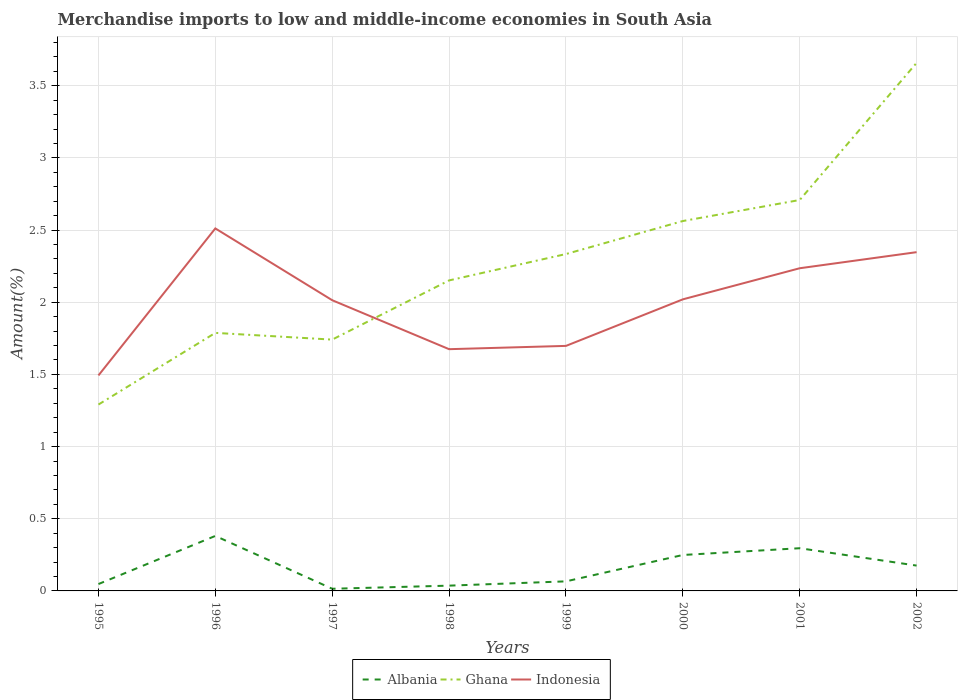Is the number of lines equal to the number of legend labels?
Offer a terse response. Yes. Across all years, what is the maximum percentage of amount earned from merchandise imports in Indonesia?
Provide a short and direct response. 1.49. In which year was the percentage of amount earned from merchandise imports in Ghana maximum?
Offer a terse response. 1995. What is the total percentage of amount earned from merchandise imports in Ghana in the graph?
Provide a succinct answer. -0.97. What is the difference between the highest and the second highest percentage of amount earned from merchandise imports in Ghana?
Offer a very short reply. 2.37. How many years are there in the graph?
Ensure brevity in your answer.  8. What is the difference between two consecutive major ticks on the Y-axis?
Ensure brevity in your answer.  0.5. What is the title of the graph?
Give a very brief answer. Merchandise imports to low and middle-income economies in South Asia. Does "Burkina Faso" appear as one of the legend labels in the graph?
Provide a succinct answer. No. What is the label or title of the X-axis?
Provide a short and direct response. Years. What is the label or title of the Y-axis?
Offer a terse response. Amount(%). What is the Amount(%) in Albania in 1995?
Provide a succinct answer. 0.05. What is the Amount(%) of Ghana in 1995?
Offer a terse response. 1.29. What is the Amount(%) in Indonesia in 1995?
Your answer should be compact. 1.49. What is the Amount(%) of Albania in 1996?
Offer a terse response. 0.38. What is the Amount(%) of Ghana in 1996?
Your response must be concise. 1.79. What is the Amount(%) of Indonesia in 1996?
Your answer should be compact. 2.51. What is the Amount(%) in Albania in 1997?
Ensure brevity in your answer.  0.01. What is the Amount(%) in Ghana in 1997?
Offer a very short reply. 1.74. What is the Amount(%) of Indonesia in 1997?
Ensure brevity in your answer.  2.01. What is the Amount(%) in Albania in 1998?
Offer a terse response. 0.04. What is the Amount(%) in Ghana in 1998?
Ensure brevity in your answer.  2.15. What is the Amount(%) of Indonesia in 1998?
Offer a very short reply. 1.67. What is the Amount(%) of Albania in 1999?
Your response must be concise. 0.07. What is the Amount(%) of Ghana in 1999?
Your response must be concise. 2.33. What is the Amount(%) in Indonesia in 1999?
Make the answer very short. 1.7. What is the Amount(%) in Albania in 2000?
Offer a very short reply. 0.25. What is the Amount(%) in Ghana in 2000?
Keep it short and to the point. 2.56. What is the Amount(%) of Indonesia in 2000?
Keep it short and to the point. 2.02. What is the Amount(%) in Albania in 2001?
Give a very brief answer. 0.3. What is the Amount(%) of Ghana in 2001?
Give a very brief answer. 2.71. What is the Amount(%) in Indonesia in 2001?
Provide a short and direct response. 2.24. What is the Amount(%) of Albania in 2002?
Ensure brevity in your answer.  0.18. What is the Amount(%) in Ghana in 2002?
Ensure brevity in your answer.  3.66. What is the Amount(%) of Indonesia in 2002?
Offer a very short reply. 2.35. Across all years, what is the maximum Amount(%) of Albania?
Offer a very short reply. 0.38. Across all years, what is the maximum Amount(%) of Ghana?
Keep it short and to the point. 3.66. Across all years, what is the maximum Amount(%) in Indonesia?
Provide a short and direct response. 2.51. Across all years, what is the minimum Amount(%) in Albania?
Your response must be concise. 0.01. Across all years, what is the minimum Amount(%) of Ghana?
Ensure brevity in your answer.  1.29. Across all years, what is the minimum Amount(%) in Indonesia?
Make the answer very short. 1.49. What is the total Amount(%) of Albania in the graph?
Ensure brevity in your answer.  1.27. What is the total Amount(%) of Ghana in the graph?
Your response must be concise. 18.24. What is the total Amount(%) in Indonesia in the graph?
Ensure brevity in your answer.  15.99. What is the difference between the Amount(%) in Albania in 1995 and that in 1996?
Make the answer very short. -0.33. What is the difference between the Amount(%) in Ghana in 1995 and that in 1996?
Your response must be concise. -0.5. What is the difference between the Amount(%) in Indonesia in 1995 and that in 1996?
Your response must be concise. -1.02. What is the difference between the Amount(%) of Albania in 1995 and that in 1997?
Your response must be concise. 0.03. What is the difference between the Amount(%) of Ghana in 1995 and that in 1997?
Provide a succinct answer. -0.45. What is the difference between the Amount(%) in Indonesia in 1995 and that in 1997?
Offer a very short reply. -0.52. What is the difference between the Amount(%) in Albania in 1995 and that in 1998?
Your answer should be compact. 0.01. What is the difference between the Amount(%) of Ghana in 1995 and that in 1998?
Provide a succinct answer. -0.86. What is the difference between the Amount(%) of Indonesia in 1995 and that in 1998?
Make the answer very short. -0.18. What is the difference between the Amount(%) in Albania in 1995 and that in 1999?
Your answer should be very brief. -0.02. What is the difference between the Amount(%) in Ghana in 1995 and that in 1999?
Your answer should be very brief. -1.04. What is the difference between the Amount(%) of Indonesia in 1995 and that in 1999?
Give a very brief answer. -0.2. What is the difference between the Amount(%) of Albania in 1995 and that in 2000?
Your answer should be very brief. -0.2. What is the difference between the Amount(%) in Ghana in 1995 and that in 2000?
Offer a terse response. -1.27. What is the difference between the Amount(%) in Indonesia in 1995 and that in 2000?
Give a very brief answer. -0.53. What is the difference between the Amount(%) of Albania in 1995 and that in 2001?
Provide a succinct answer. -0.25. What is the difference between the Amount(%) of Ghana in 1995 and that in 2001?
Provide a succinct answer. -1.42. What is the difference between the Amount(%) in Indonesia in 1995 and that in 2001?
Offer a very short reply. -0.74. What is the difference between the Amount(%) of Albania in 1995 and that in 2002?
Provide a short and direct response. -0.13. What is the difference between the Amount(%) of Ghana in 1995 and that in 2002?
Provide a succinct answer. -2.37. What is the difference between the Amount(%) in Indonesia in 1995 and that in 2002?
Provide a succinct answer. -0.85. What is the difference between the Amount(%) of Albania in 1996 and that in 1997?
Ensure brevity in your answer.  0.37. What is the difference between the Amount(%) in Ghana in 1996 and that in 1997?
Make the answer very short. 0.05. What is the difference between the Amount(%) of Indonesia in 1996 and that in 1997?
Provide a short and direct response. 0.5. What is the difference between the Amount(%) of Albania in 1996 and that in 1998?
Your response must be concise. 0.34. What is the difference between the Amount(%) of Ghana in 1996 and that in 1998?
Your answer should be compact. -0.36. What is the difference between the Amount(%) of Indonesia in 1996 and that in 1998?
Provide a short and direct response. 0.84. What is the difference between the Amount(%) of Albania in 1996 and that in 1999?
Your answer should be very brief. 0.31. What is the difference between the Amount(%) in Ghana in 1996 and that in 1999?
Your answer should be compact. -0.55. What is the difference between the Amount(%) in Indonesia in 1996 and that in 1999?
Your response must be concise. 0.81. What is the difference between the Amount(%) of Albania in 1996 and that in 2000?
Make the answer very short. 0.13. What is the difference between the Amount(%) in Ghana in 1996 and that in 2000?
Your answer should be very brief. -0.78. What is the difference between the Amount(%) in Indonesia in 1996 and that in 2000?
Ensure brevity in your answer.  0.49. What is the difference between the Amount(%) of Albania in 1996 and that in 2001?
Give a very brief answer. 0.09. What is the difference between the Amount(%) of Ghana in 1996 and that in 2001?
Keep it short and to the point. -0.92. What is the difference between the Amount(%) in Indonesia in 1996 and that in 2001?
Provide a short and direct response. 0.28. What is the difference between the Amount(%) in Albania in 1996 and that in 2002?
Offer a very short reply. 0.21. What is the difference between the Amount(%) in Ghana in 1996 and that in 2002?
Provide a succinct answer. -1.87. What is the difference between the Amount(%) of Indonesia in 1996 and that in 2002?
Ensure brevity in your answer.  0.16. What is the difference between the Amount(%) of Albania in 1997 and that in 1998?
Your answer should be compact. -0.02. What is the difference between the Amount(%) in Ghana in 1997 and that in 1998?
Your response must be concise. -0.41. What is the difference between the Amount(%) in Indonesia in 1997 and that in 1998?
Your answer should be compact. 0.34. What is the difference between the Amount(%) of Albania in 1997 and that in 1999?
Your response must be concise. -0.05. What is the difference between the Amount(%) in Ghana in 1997 and that in 1999?
Keep it short and to the point. -0.59. What is the difference between the Amount(%) in Indonesia in 1997 and that in 1999?
Provide a succinct answer. 0.32. What is the difference between the Amount(%) in Albania in 1997 and that in 2000?
Your answer should be very brief. -0.23. What is the difference between the Amount(%) of Ghana in 1997 and that in 2000?
Give a very brief answer. -0.82. What is the difference between the Amount(%) in Indonesia in 1997 and that in 2000?
Provide a succinct answer. -0.01. What is the difference between the Amount(%) of Albania in 1997 and that in 2001?
Your response must be concise. -0.28. What is the difference between the Amount(%) in Ghana in 1997 and that in 2001?
Provide a short and direct response. -0.97. What is the difference between the Amount(%) in Indonesia in 1997 and that in 2001?
Give a very brief answer. -0.22. What is the difference between the Amount(%) in Albania in 1997 and that in 2002?
Provide a short and direct response. -0.16. What is the difference between the Amount(%) in Ghana in 1997 and that in 2002?
Your response must be concise. -1.92. What is the difference between the Amount(%) of Indonesia in 1997 and that in 2002?
Your answer should be very brief. -0.33. What is the difference between the Amount(%) of Albania in 1998 and that in 1999?
Ensure brevity in your answer.  -0.03. What is the difference between the Amount(%) of Ghana in 1998 and that in 1999?
Your answer should be compact. -0.18. What is the difference between the Amount(%) in Indonesia in 1998 and that in 1999?
Your response must be concise. -0.02. What is the difference between the Amount(%) of Albania in 1998 and that in 2000?
Give a very brief answer. -0.21. What is the difference between the Amount(%) of Ghana in 1998 and that in 2000?
Give a very brief answer. -0.41. What is the difference between the Amount(%) in Indonesia in 1998 and that in 2000?
Provide a short and direct response. -0.35. What is the difference between the Amount(%) in Albania in 1998 and that in 2001?
Offer a very short reply. -0.26. What is the difference between the Amount(%) of Ghana in 1998 and that in 2001?
Your answer should be compact. -0.56. What is the difference between the Amount(%) of Indonesia in 1998 and that in 2001?
Offer a terse response. -0.56. What is the difference between the Amount(%) in Albania in 1998 and that in 2002?
Keep it short and to the point. -0.14. What is the difference between the Amount(%) in Ghana in 1998 and that in 2002?
Keep it short and to the point. -1.51. What is the difference between the Amount(%) in Indonesia in 1998 and that in 2002?
Keep it short and to the point. -0.67. What is the difference between the Amount(%) in Albania in 1999 and that in 2000?
Your response must be concise. -0.18. What is the difference between the Amount(%) of Ghana in 1999 and that in 2000?
Your answer should be compact. -0.23. What is the difference between the Amount(%) of Indonesia in 1999 and that in 2000?
Provide a short and direct response. -0.32. What is the difference between the Amount(%) in Albania in 1999 and that in 2001?
Provide a succinct answer. -0.23. What is the difference between the Amount(%) of Ghana in 1999 and that in 2001?
Provide a short and direct response. -0.37. What is the difference between the Amount(%) of Indonesia in 1999 and that in 2001?
Provide a succinct answer. -0.54. What is the difference between the Amount(%) in Albania in 1999 and that in 2002?
Make the answer very short. -0.11. What is the difference between the Amount(%) of Ghana in 1999 and that in 2002?
Your answer should be compact. -1.32. What is the difference between the Amount(%) of Indonesia in 1999 and that in 2002?
Your answer should be very brief. -0.65. What is the difference between the Amount(%) of Albania in 2000 and that in 2001?
Provide a succinct answer. -0.05. What is the difference between the Amount(%) of Ghana in 2000 and that in 2001?
Your response must be concise. -0.15. What is the difference between the Amount(%) in Indonesia in 2000 and that in 2001?
Your answer should be compact. -0.22. What is the difference between the Amount(%) in Albania in 2000 and that in 2002?
Offer a terse response. 0.07. What is the difference between the Amount(%) in Ghana in 2000 and that in 2002?
Give a very brief answer. -1.1. What is the difference between the Amount(%) of Indonesia in 2000 and that in 2002?
Your answer should be very brief. -0.33. What is the difference between the Amount(%) of Albania in 2001 and that in 2002?
Offer a very short reply. 0.12. What is the difference between the Amount(%) of Ghana in 2001 and that in 2002?
Make the answer very short. -0.95. What is the difference between the Amount(%) in Indonesia in 2001 and that in 2002?
Your response must be concise. -0.11. What is the difference between the Amount(%) of Albania in 1995 and the Amount(%) of Ghana in 1996?
Provide a succinct answer. -1.74. What is the difference between the Amount(%) of Albania in 1995 and the Amount(%) of Indonesia in 1996?
Provide a short and direct response. -2.46. What is the difference between the Amount(%) of Ghana in 1995 and the Amount(%) of Indonesia in 1996?
Make the answer very short. -1.22. What is the difference between the Amount(%) of Albania in 1995 and the Amount(%) of Ghana in 1997?
Your answer should be very brief. -1.69. What is the difference between the Amount(%) in Albania in 1995 and the Amount(%) in Indonesia in 1997?
Your answer should be compact. -1.97. What is the difference between the Amount(%) in Ghana in 1995 and the Amount(%) in Indonesia in 1997?
Your answer should be very brief. -0.72. What is the difference between the Amount(%) in Albania in 1995 and the Amount(%) in Ghana in 1998?
Your answer should be very brief. -2.1. What is the difference between the Amount(%) in Albania in 1995 and the Amount(%) in Indonesia in 1998?
Provide a succinct answer. -1.63. What is the difference between the Amount(%) in Ghana in 1995 and the Amount(%) in Indonesia in 1998?
Offer a terse response. -0.38. What is the difference between the Amount(%) of Albania in 1995 and the Amount(%) of Ghana in 1999?
Your answer should be compact. -2.29. What is the difference between the Amount(%) of Albania in 1995 and the Amount(%) of Indonesia in 1999?
Keep it short and to the point. -1.65. What is the difference between the Amount(%) in Ghana in 1995 and the Amount(%) in Indonesia in 1999?
Offer a terse response. -0.41. What is the difference between the Amount(%) of Albania in 1995 and the Amount(%) of Ghana in 2000?
Give a very brief answer. -2.52. What is the difference between the Amount(%) of Albania in 1995 and the Amount(%) of Indonesia in 2000?
Ensure brevity in your answer.  -1.97. What is the difference between the Amount(%) of Ghana in 1995 and the Amount(%) of Indonesia in 2000?
Your answer should be compact. -0.73. What is the difference between the Amount(%) in Albania in 1995 and the Amount(%) in Ghana in 2001?
Offer a very short reply. -2.66. What is the difference between the Amount(%) in Albania in 1995 and the Amount(%) in Indonesia in 2001?
Provide a succinct answer. -2.19. What is the difference between the Amount(%) of Ghana in 1995 and the Amount(%) of Indonesia in 2001?
Provide a short and direct response. -0.94. What is the difference between the Amount(%) in Albania in 1995 and the Amount(%) in Ghana in 2002?
Keep it short and to the point. -3.61. What is the difference between the Amount(%) of Albania in 1995 and the Amount(%) of Indonesia in 2002?
Your answer should be very brief. -2.3. What is the difference between the Amount(%) in Ghana in 1995 and the Amount(%) in Indonesia in 2002?
Your answer should be very brief. -1.06. What is the difference between the Amount(%) of Albania in 1996 and the Amount(%) of Ghana in 1997?
Give a very brief answer. -1.36. What is the difference between the Amount(%) in Albania in 1996 and the Amount(%) in Indonesia in 1997?
Give a very brief answer. -1.63. What is the difference between the Amount(%) of Ghana in 1996 and the Amount(%) of Indonesia in 1997?
Provide a short and direct response. -0.23. What is the difference between the Amount(%) of Albania in 1996 and the Amount(%) of Ghana in 1998?
Your response must be concise. -1.77. What is the difference between the Amount(%) of Albania in 1996 and the Amount(%) of Indonesia in 1998?
Provide a succinct answer. -1.29. What is the difference between the Amount(%) in Ghana in 1996 and the Amount(%) in Indonesia in 1998?
Provide a short and direct response. 0.11. What is the difference between the Amount(%) in Albania in 1996 and the Amount(%) in Ghana in 1999?
Offer a terse response. -1.95. What is the difference between the Amount(%) of Albania in 1996 and the Amount(%) of Indonesia in 1999?
Provide a succinct answer. -1.32. What is the difference between the Amount(%) in Ghana in 1996 and the Amount(%) in Indonesia in 1999?
Your response must be concise. 0.09. What is the difference between the Amount(%) of Albania in 1996 and the Amount(%) of Ghana in 2000?
Your response must be concise. -2.18. What is the difference between the Amount(%) in Albania in 1996 and the Amount(%) in Indonesia in 2000?
Your response must be concise. -1.64. What is the difference between the Amount(%) of Ghana in 1996 and the Amount(%) of Indonesia in 2000?
Keep it short and to the point. -0.23. What is the difference between the Amount(%) of Albania in 1996 and the Amount(%) of Ghana in 2001?
Provide a succinct answer. -2.33. What is the difference between the Amount(%) in Albania in 1996 and the Amount(%) in Indonesia in 2001?
Make the answer very short. -1.85. What is the difference between the Amount(%) of Ghana in 1996 and the Amount(%) of Indonesia in 2001?
Make the answer very short. -0.45. What is the difference between the Amount(%) of Albania in 1996 and the Amount(%) of Ghana in 2002?
Provide a short and direct response. -3.28. What is the difference between the Amount(%) in Albania in 1996 and the Amount(%) in Indonesia in 2002?
Your answer should be compact. -1.97. What is the difference between the Amount(%) in Ghana in 1996 and the Amount(%) in Indonesia in 2002?
Your response must be concise. -0.56. What is the difference between the Amount(%) in Albania in 1997 and the Amount(%) in Ghana in 1998?
Ensure brevity in your answer.  -2.14. What is the difference between the Amount(%) in Albania in 1997 and the Amount(%) in Indonesia in 1998?
Provide a short and direct response. -1.66. What is the difference between the Amount(%) in Ghana in 1997 and the Amount(%) in Indonesia in 1998?
Offer a terse response. 0.07. What is the difference between the Amount(%) in Albania in 1997 and the Amount(%) in Ghana in 1999?
Give a very brief answer. -2.32. What is the difference between the Amount(%) in Albania in 1997 and the Amount(%) in Indonesia in 1999?
Your answer should be very brief. -1.68. What is the difference between the Amount(%) in Ghana in 1997 and the Amount(%) in Indonesia in 1999?
Offer a terse response. 0.04. What is the difference between the Amount(%) in Albania in 1997 and the Amount(%) in Ghana in 2000?
Provide a short and direct response. -2.55. What is the difference between the Amount(%) of Albania in 1997 and the Amount(%) of Indonesia in 2000?
Provide a succinct answer. -2.01. What is the difference between the Amount(%) of Ghana in 1997 and the Amount(%) of Indonesia in 2000?
Provide a short and direct response. -0.28. What is the difference between the Amount(%) of Albania in 1997 and the Amount(%) of Ghana in 2001?
Offer a very short reply. -2.69. What is the difference between the Amount(%) of Albania in 1997 and the Amount(%) of Indonesia in 2001?
Your response must be concise. -2.22. What is the difference between the Amount(%) of Ghana in 1997 and the Amount(%) of Indonesia in 2001?
Keep it short and to the point. -0.49. What is the difference between the Amount(%) in Albania in 1997 and the Amount(%) in Ghana in 2002?
Offer a very short reply. -3.64. What is the difference between the Amount(%) in Albania in 1997 and the Amount(%) in Indonesia in 2002?
Make the answer very short. -2.33. What is the difference between the Amount(%) in Ghana in 1997 and the Amount(%) in Indonesia in 2002?
Provide a short and direct response. -0.61. What is the difference between the Amount(%) in Albania in 1998 and the Amount(%) in Ghana in 1999?
Give a very brief answer. -2.3. What is the difference between the Amount(%) in Albania in 1998 and the Amount(%) in Indonesia in 1999?
Provide a short and direct response. -1.66. What is the difference between the Amount(%) of Ghana in 1998 and the Amount(%) of Indonesia in 1999?
Keep it short and to the point. 0.45. What is the difference between the Amount(%) in Albania in 1998 and the Amount(%) in Ghana in 2000?
Provide a succinct answer. -2.53. What is the difference between the Amount(%) of Albania in 1998 and the Amount(%) of Indonesia in 2000?
Ensure brevity in your answer.  -1.98. What is the difference between the Amount(%) of Ghana in 1998 and the Amount(%) of Indonesia in 2000?
Offer a very short reply. 0.13. What is the difference between the Amount(%) in Albania in 1998 and the Amount(%) in Ghana in 2001?
Your answer should be very brief. -2.67. What is the difference between the Amount(%) in Albania in 1998 and the Amount(%) in Indonesia in 2001?
Your response must be concise. -2.2. What is the difference between the Amount(%) of Ghana in 1998 and the Amount(%) of Indonesia in 2001?
Make the answer very short. -0.08. What is the difference between the Amount(%) in Albania in 1998 and the Amount(%) in Ghana in 2002?
Give a very brief answer. -3.62. What is the difference between the Amount(%) in Albania in 1998 and the Amount(%) in Indonesia in 2002?
Keep it short and to the point. -2.31. What is the difference between the Amount(%) in Ghana in 1998 and the Amount(%) in Indonesia in 2002?
Give a very brief answer. -0.2. What is the difference between the Amount(%) in Albania in 1999 and the Amount(%) in Ghana in 2000?
Provide a succinct answer. -2.5. What is the difference between the Amount(%) of Albania in 1999 and the Amount(%) of Indonesia in 2000?
Make the answer very short. -1.95. What is the difference between the Amount(%) of Ghana in 1999 and the Amount(%) of Indonesia in 2000?
Ensure brevity in your answer.  0.31. What is the difference between the Amount(%) of Albania in 1999 and the Amount(%) of Ghana in 2001?
Ensure brevity in your answer.  -2.64. What is the difference between the Amount(%) in Albania in 1999 and the Amount(%) in Indonesia in 2001?
Your answer should be compact. -2.17. What is the difference between the Amount(%) in Ghana in 1999 and the Amount(%) in Indonesia in 2001?
Offer a terse response. 0.1. What is the difference between the Amount(%) in Albania in 1999 and the Amount(%) in Ghana in 2002?
Your answer should be very brief. -3.59. What is the difference between the Amount(%) in Albania in 1999 and the Amount(%) in Indonesia in 2002?
Keep it short and to the point. -2.28. What is the difference between the Amount(%) of Ghana in 1999 and the Amount(%) of Indonesia in 2002?
Offer a very short reply. -0.01. What is the difference between the Amount(%) of Albania in 2000 and the Amount(%) of Ghana in 2001?
Ensure brevity in your answer.  -2.46. What is the difference between the Amount(%) in Albania in 2000 and the Amount(%) in Indonesia in 2001?
Provide a short and direct response. -1.99. What is the difference between the Amount(%) in Ghana in 2000 and the Amount(%) in Indonesia in 2001?
Ensure brevity in your answer.  0.33. What is the difference between the Amount(%) in Albania in 2000 and the Amount(%) in Ghana in 2002?
Give a very brief answer. -3.41. What is the difference between the Amount(%) of Albania in 2000 and the Amount(%) of Indonesia in 2002?
Ensure brevity in your answer.  -2.1. What is the difference between the Amount(%) of Ghana in 2000 and the Amount(%) of Indonesia in 2002?
Your response must be concise. 0.22. What is the difference between the Amount(%) in Albania in 2001 and the Amount(%) in Ghana in 2002?
Ensure brevity in your answer.  -3.36. What is the difference between the Amount(%) of Albania in 2001 and the Amount(%) of Indonesia in 2002?
Make the answer very short. -2.05. What is the difference between the Amount(%) of Ghana in 2001 and the Amount(%) of Indonesia in 2002?
Offer a very short reply. 0.36. What is the average Amount(%) in Albania per year?
Your answer should be very brief. 0.16. What is the average Amount(%) in Ghana per year?
Your answer should be very brief. 2.28. What is the average Amount(%) in Indonesia per year?
Provide a succinct answer. 2. In the year 1995, what is the difference between the Amount(%) in Albania and Amount(%) in Ghana?
Ensure brevity in your answer.  -1.24. In the year 1995, what is the difference between the Amount(%) in Albania and Amount(%) in Indonesia?
Offer a very short reply. -1.45. In the year 1995, what is the difference between the Amount(%) of Ghana and Amount(%) of Indonesia?
Provide a short and direct response. -0.2. In the year 1996, what is the difference between the Amount(%) in Albania and Amount(%) in Ghana?
Give a very brief answer. -1.41. In the year 1996, what is the difference between the Amount(%) in Albania and Amount(%) in Indonesia?
Keep it short and to the point. -2.13. In the year 1996, what is the difference between the Amount(%) in Ghana and Amount(%) in Indonesia?
Offer a very short reply. -0.72. In the year 1997, what is the difference between the Amount(%) in Albania and Amount(%) in Ghana?
Ensure brevity in your answer.  -1.73. In the year 1997, what is the difference between the Amount(%) in Albania and Amount(%) in Indonesia?
Make the answer very short. -2. In the year 1997, what is the difference between the Amount(%) in Ghana and Amount(%) in Indonesia?
Your answer should be very brief. -0.27. In the year 1998, what is the difference between the Amount(%) in Albania and Amount(%) in Ghana?
Keep it short and to the point. -2.11. In the year 1998, what is the difference between the Amount(%) in Albania and Amount(%) in Indonesia?
Your answer should be very brief. -1.64. In the year 1998, what is the difference between the Amount(%) of Ghana and Amount(%) of Indonesia?
Ensure brevity in your answer.  0.48. In the year 1999, what is the difference between the Amount(%) of Albania and Amount(%) of Ghana?
Your response must be concise. -2.27. In the year 1999, what is the difference between the Amount(%) of Albania and Amount(%) of Indonesia?
Provide a succinct answer. -1.63. In the year 1999, what is the difference between the Amount(%) of Ghana and Amount(%) of Indonesia?
Keep it short and to the point. 0.64. In the year 2000, what is the difference between the Amount(%) in Albania and Amount(%) in Ghana?
Ensure brevity in your answer.  -2.31. In the year 2000, what is the difference between the Amount(%) of Albania and Amount(%) of Indonesia?
Your answer should be compact. -1.77. In the year 2000, what is the difference between the Amount(%) of Ghana and Amount(%) of Indonesia?
Your answer should be compact. 0.54. In the year 2001, what is the difference between the Amount(%) of Albania and Amount(%) of Ghana?
Make the answer very short. -2.41. In the year 2001, what is the difference between the Amount(%) of Albania and Amount(%) of Indonesia?
Offer a terse response. -1.94. In the year 2001, what is the difference between the Amount(%) of Ghana and Amount(%) of Indonesia?
Offer a very short reply. 0.47. In the year 2002, what is the difference between the Amount(%) in Albania and Amount(%) in Ghana?
Make the answer very short. -3.48. In the year 2002, what is the difference between the Amount(%) of Albania and Amount(%) of Indonesia?
Your response must be concise. -2.17. In the year 2002, what is the difference between the Amount(%) in Ghana and Amount(%) in Indonesia?
Give a very brief answer. 1.31. What is the ratio of the Amount(%) of Albania in 1995 to that in 1996?
Provide a short and direct response. 0.12. What is the ratio of the Amount(%) in Ghana in 1995 to that in 1996?
Offer a very short reply. 0.72. What is the ratio of the Amount(%) in Indonesia in 1995 to that in 1996?
Your response must be concise. 0.59. What is the ratio of the Amount(%) of Albania in 1995 to that in 1997?
Your response must be concise. 3.18. What is the ratio of the Amount(%) in Ghana in 1995 to that in 1997?
Your answer should be very brief. 0.74. What is the ratio of the Amount(%) of Indonesia in 1995 to that in 1997?
Offer a very short reply. 0.74. What is the ratio of the Amount(%) of Albania in 1995 to that in 1998?
Give a very brief answer. 1.3. What is the ratio of the Amount(%) of Ghana in 1995 to that in 1998?
Offer a terse response. 0.6. What is the ratio of the Amount(%) of Indonesia in 1995 to that in 1998?
Your response must be concise. 0.89. What is the ratio of the Amount(%) in Albania in 1995 to that in 1999?
Offer a very short reply. 0.72. What is the ratio of the Amount(%) in Ghana in 1995 to that in 1999?
Your answer should be very brief. 0.55. What is the ratio of the Amount(%) in Indonesia in 1995 to that in 1999?
Your answer should be compact. 0.88. What is the ratio of the Amount(%) in Albania in 1995 to that in 2000?
Provide a short and direct response. 0.19. What is the ratio of the Amount(%) of Ghana in 1995 to that in 2000?
Keep it short and to the point. 0.5. What is the ratio of the Amount(%) in Indonesia in 1995 to that in 2000?
Offer a very short reply. 0.74. What is the ratio of the Amount(%) in Albania in 1995 to that in 2001?
Offer a very short reply. 0.16. What is the ratio of the Amount(%) of Ghana in 1995 to that in 2001?
Offer a terse response. 0.48. What is the ratio of the Amount(%) in Indonesia in 1995 to that in 2001?
Offer a terse response. 0.67. What is the ratio of the Amount(%) of Albania in 1995 to that in 2002?
Your response must be concise. 0.27. What is the ratio of the Amount(%) in Ghana in 1995 to that in 2002?
Provide a succinct answer. 0.35. What is the ratio of the Amount(%) in Indonesia in 1995 to that in 2002?
Your answer should be compact. 0.64. What is the ratio of the Amount(%) of Albania in 1996 to that in 1997?
Give a very brief answer. 25.44. What is the ratio of the Amount(%) of Ghana in 1996 to that in 1997?
Provide a short and direct response. 1.03. What is the ratio of the Amount(%) in Indonesia in 1996 to that in 1997?
Keep it short and to the point. 1.25. What is the ratio of the Amount(%) of Albania in 1996 to that in 1998?
Your answer should be compact. 10.41. What is the ratio of the Amount(%) in Ghana in 1996 to that in 1998?
Your answer should be very brief. 0.83. What is the ratio of the Amount(%) in Indonesia in 1996 to that in 1998?
Make the answer very short. 1.5. What is the ratio of the Amount(%) in Albania in 1996 to that in 1999?
Keep it short and to the point. 5.75. What is the ratio of the Amount(%) in Ghana in 1996 to that in 1999?
Provide a succinct answer. 0.77. What is the ratio of the Amount(%) in Indonesia in 1996 to that in 1999?
Your response must be concise. 1.48. What is the ratio of the Amount(%) in Albania in 1996 to that in 2000?
Provide a short and direct response. 1.53. What is the ratio of the Amount(%) of Ghana in 1996 to that in 2000?
Provide a succinct answer. 0.7. What is the ratio of the Amount(%) of Indonesia in 1996 to that in 2000?
Your response must be concise. 1.24. What is the ratio of the Amount(%) of Albania in 1996 to that in 2001?
Ensure brevity in your answer.  1.29. What is the ratio of the Amount(%) of Ghana in 1996 to that in 2001?
Ensure brevity in your answer.  0.66. What is the ratio of the Amount(%) in Indonesia in 1996 to that in 2001?
Your answer should be compact. 1.12. What is the ratio of the Amount(%) in Albania in 1996 to that in 2002?
Offer a very short reply. 2.17. What is the ratio of the Amount(%) of Ghana in 1996 to that in 2002?
Your answer should be compact. 0.49. What is the ratio of the Amount(%) of Indonesia in 1996 to that in 2002?
Provide a succinct answer. 1.07. What is the ratio of the Amount(%) of Albania in 1997 to that in 1998?
Your answer should be compact. 0.41. What is the ratio of the Amount(%) in Ghana in 1997 to that in 1998?
Offer a very short reply. 0.81. What is the ratio of the Amount(%) of Indonesia in 1997 to that in 1998?
Provide a succinct answer. 1.2. What is the ratio of the Amount(%) of Albania in 1997 to that in 1999?
Offer a terse response. 0.23. What is the ratio of the Amount(%) in Ghana in 1997 to that in 1999?
Provide a short and direct response. 0.75. What is the ratio of the Amount(%) of Indonesia in 1997 to that in 1999?
Provide a short and direct response. 1.19. What is the ratio of the Amount(%) in Albania in 1997 to that in 2000?
Offer a very short reply. 0.06. What is the ratio of the Amount(%) of Ghana in 1997 to that in 2000?
Provide a short and direct response. 0.68. What is the ratio of the Amount(%) of Indonesia in 1997 to that in 2000?
Make the answer very short. 1. What is the ratio of the Amount(%) in Albania in 1997 to that in 2001?
Your response must be concise. 0.05. What is the ratio of the Amount(%) in Ghana in 1997 to that in 2001?
Your response must be concise. 0.64. What is the ratio of the Amount(%) in Indonesia in 1997 to that in 2001?
Offer a very short reply. 0.9. What is the ratio of the Amount(%) in Albania in 1997 to that in 2002?
Keep it short and to the point. 0.09. What is the ratio of the Amount(%) in Ghana in 1997 to that in 2002?
Keep it short and to the point. 0.48. What is the ratio of the Amount(%) of Indonesia in 1997 to that in 2002?
Ensure brevity in your answer.  0.86. What is the ratio of the Amount(%) of Albania in 1998 to that in 1999?
Provide a succinct answer. 0.55. What is the ratio of the Amount(%) of Ghana in 1998 to that in 1999?
Provide a short and direct response. 0.92. What is the ratio of the Amount(%) of Indonesia in 1998 to that in 1999?
Your response must be concise. 0.99. What is the ratio of the Amount(%) of Albania in 1998 to that in 2000?
Your response must be concise. 0.15. What is the ratio of the Amount(%) in Ghana in 1998 to that in 2000?
Keep it short and to the point. 0.84. What is the ratio of the Amount(%) in Indonesia in 1998 to that in 2000?
Keep it short and to the point. 0.83. What is the ratio of the Amount(%) of Albania in 1998 to that in 2001?
Keep it short and to the point. 0.12. What is the ratio of the Amount(%) in Ghana in 1998 to that in 2001?
Give a very brief answer. 0.79. What is the ratio of the Amount(%) in Indonesia in 1998 to that in 2001?
Offer a terse response. 0.75. What is the ratio of the Amount(%) in Albania in 1998 to that in 2002?
Your answer should be compact. 0.21. What is the ratio of the Amount(%) of Ghana in 1998 to that in 2002?
Your response must be concise. 0.59. What is the ratio of the Amount(%) of Indonesia in 1998 to that in 2002?
Give a very brief answer. 0.71. What is the ratio of the Amount(%) in Albania in 1999 to that in 2000?
Keep it short and to the point. 0.27. What is the ratio of the Amount(%) of Ghana in 1999 to that in 2000?
Offer a terse response. 0.91. What is the ratio of the Amount(%) in Indonesia in 1999 to that in 2000?
Keep it short and to the point. 0.84. What is the ratio of the Amount(%) in Albania in 1999 to that in 2001?
Provide a short and direct response. 0.22. What is the ratio of the Amount(%) in Ghana in 1999 to that in 2001?
Make the answer very short. 0.86. What is the ratio of the Amount(%) of Indonesia in 1999 to that in 2001?
Offer a very short reply. 0.76. What is the ratio of the Amount(%) in Albania in 1999 to that in 2002?
Provide a short and direct response. 0.38. What is the ratio of the Amount(%) in Ghana in 1999 to that in 2002?
Your response must be concise. 0.64. What is the ratio of the Amount(%) in Indonesia in 1999 to that in 2002?
Offer a terse response. 0.72. What is the ratio of the Amount(%) of Albania in 2000 to that in 2001?
Ensure brevity in your answer.  0.84. What is the ratio of the Amount(%) of Ghana in 2000 to that in 2001?
Offer a terse response. 0.95. What is the ratio of the Amount(%) in Indonesia in 2000 to that in 2001?
Your response must be concise. 0.9. What is the ratio of the Amount(%) in Albania in 2000 to that in 2002?
Provide a short and direct response. 1.42. What is the ratio of the Amount(%) in Ghana in 2000 to that in 2002?
Keep it short and to the point. 0.7. What is the ratio of the Amount(%) of Indonesia in 2000 to that in 2002?
Provide a short and direct response. 0.86. What is the ratio of the Amount(%) in Albania in 2001 to that in 2002?
Offer a terse response. 1.69. What is the ratio of the Amount(%) in Ghana in 2001 to that in 2002?
Offer a very short reply. 0.74. What is the ratio of the Amount(%) in Indonesia in 2001 to that in 2002?
Your answer should be compact. 0.95. What is the difference between the highest and the second highest Amount(%) of Albania?
Ensure brevity in your answer.  0.09. What is the difference between the highest and the second highest Amount(%) of Ghana?
Provide a succinct answer. 0.95. What is the difference between the highest and the second highest Amount(%) of Indonesia?
Offer a very short reply. 0.16. What is the difference between the highest and the lowest Amount(%) in Albania?
Ensure brevity in your answer.  0.37. What is the difference between the highest and the lowest Amount(%) of Ghana?
Make the answer very short. 2.37. What is the difference between the highest and the lowest Amount(%) in Indonesia?
Keep it short and to the point. 1.02. 